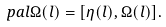<formula> <loc_0><loc_0><loc_500><loc_500>\ p a l \Omega ( l ) = [ \eta ( l ) , \Omega ( l ) ] .</formula> 